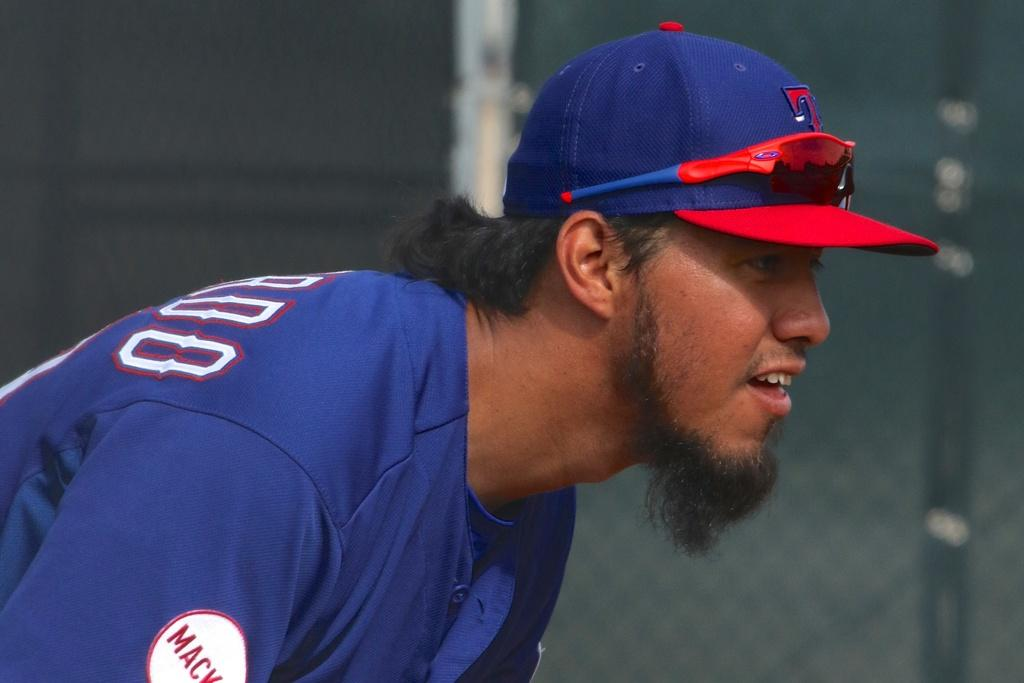What is the main subject of the image? There is a person in the image. What is the person wearing on their upper body? The person is wearing a blue shirt. What can be seen on the person's head? The person is wearing a hat with blue and red colors. What is the person's posture in the image? The person is standing. How would you describe the background of the image? The background of the image is blurry. What type of plants can be seen growing inside the drawer in the image? There is no drawer or plants present in the image. What type of camera is the person using to take the picture in the image? There is no camera visible in the image, and it is not clear if the person is taking a picture. 